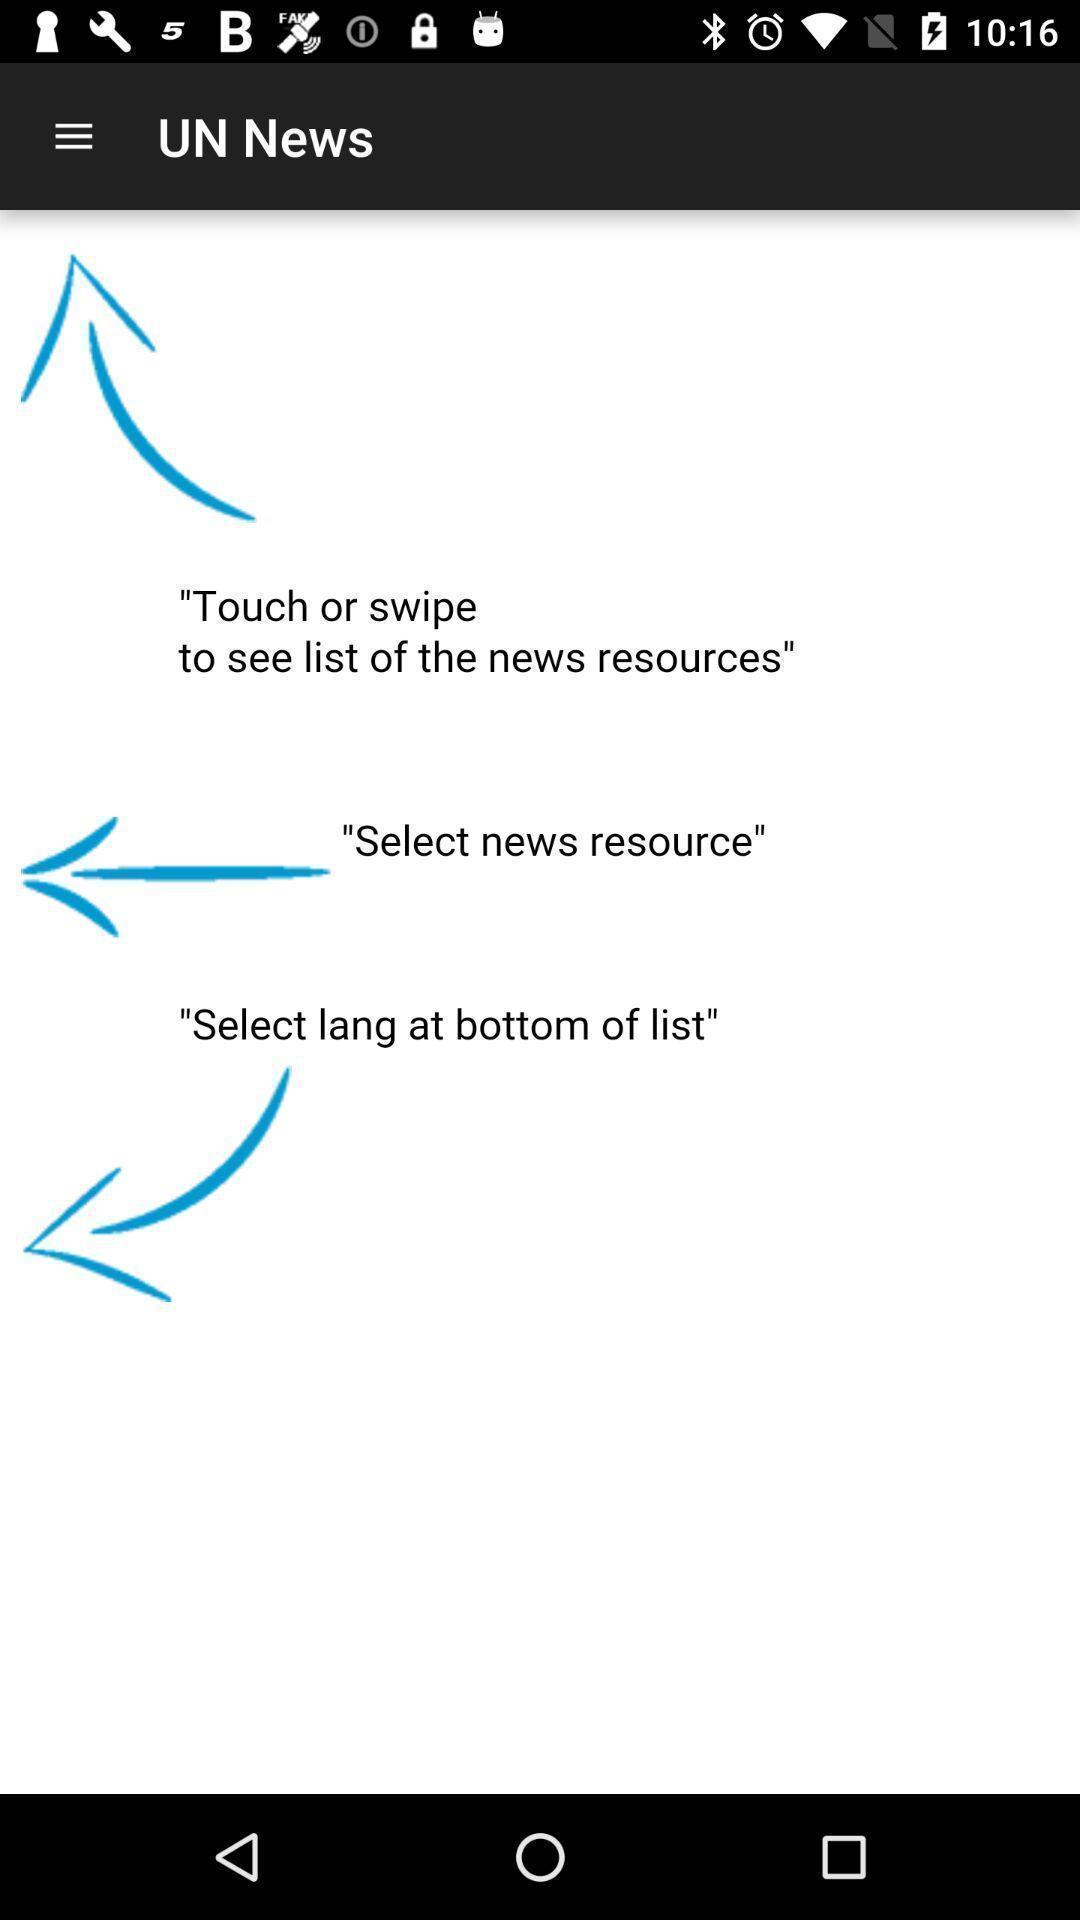Provide a description of this screenshot. Page with instructions for using a news app. 